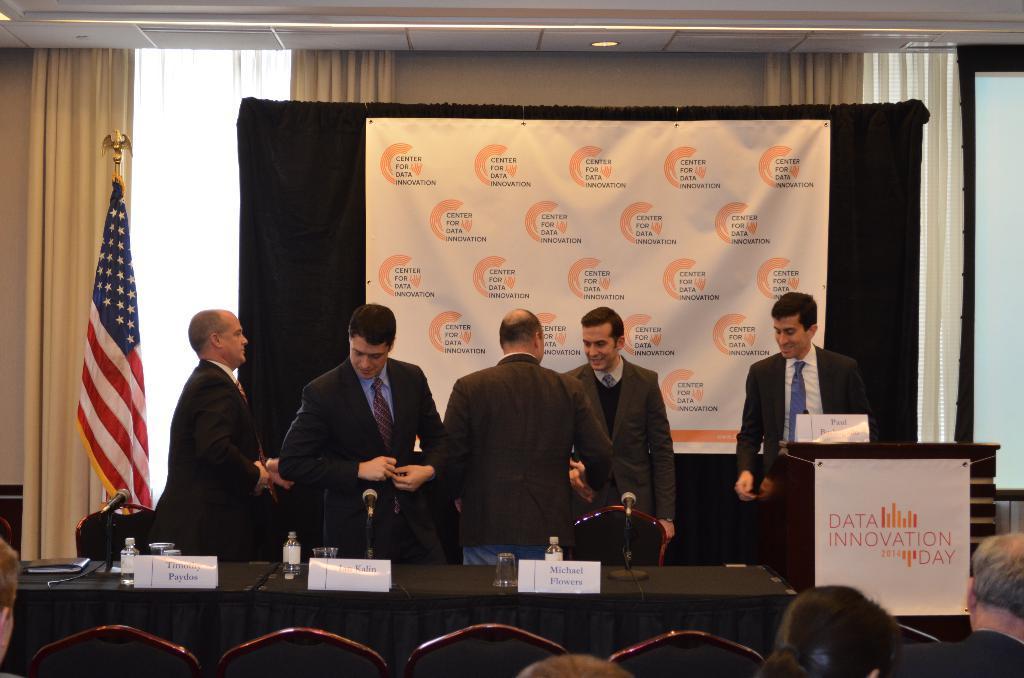In one or two sentences, can you explain what this image depicts? In the picture we can see group of persons wearing suit standing behind table on which there are some name boards, glasses, bottles, there is wooden podium to which poster is attached, in the foreground of the picture there are some chairs on which persons sitting and in the background of the picture there is flag, there is black color screen and there is curtain. 